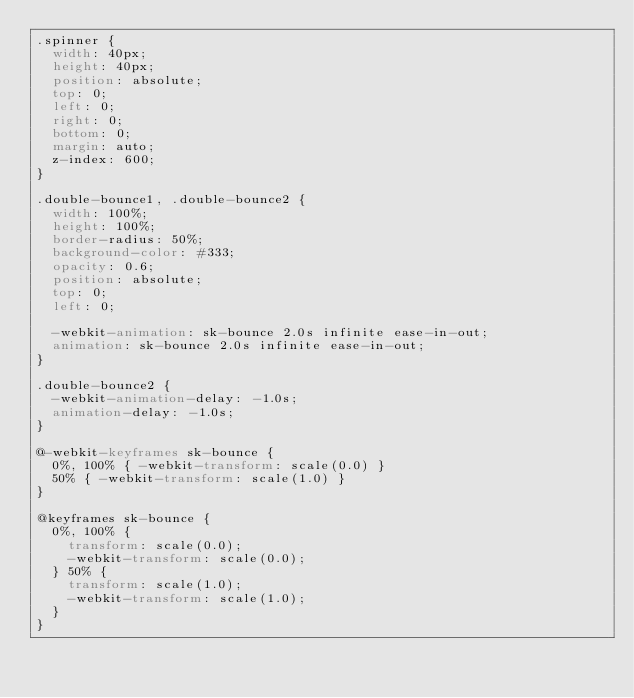<code> <loc_0><loc_0><loc_500><loc_500><_CSS_>.spinner {
  width: 40px;
  height: 40px;
  position: absolute;
  top: 0;
  left: 0;
  right: 0;
  bottom: 0;
  margin: auto;
  z-index: 600;
}

.double-bounce1, .double-bounce2 {
  width: 100%;
  height: 100%;
  border-radius: 50%;
  background-color: #333;
  opacity: 0.6;
  position: absolute;
  top: 0;
  left: 0;
  
  -webkit-animation: sk-bounce 2.0s infinite ease-in-out;
  animation: sk-bounce 2.0s infinite ease-in-out;
}

.double-bounce2 {
  -webkit-animation-delay: -1.0s;
  animation-delay: -1.0s;
}

@-webkit-keyframes sk-bounce {
  0%, 100% { -webkit-transform: scale(0.0) }
  50% { -webkit-transform: scale(1.0) }
}

@keyframes sk-bounce {
  0%, 100% { 
    transform: scale(0.0);
    -webkit-transform: scale(0.0);
  } 50% { 
    transform: scale(1.0);
    -webkit-transform: scale(1.0);
  }
}</code> 